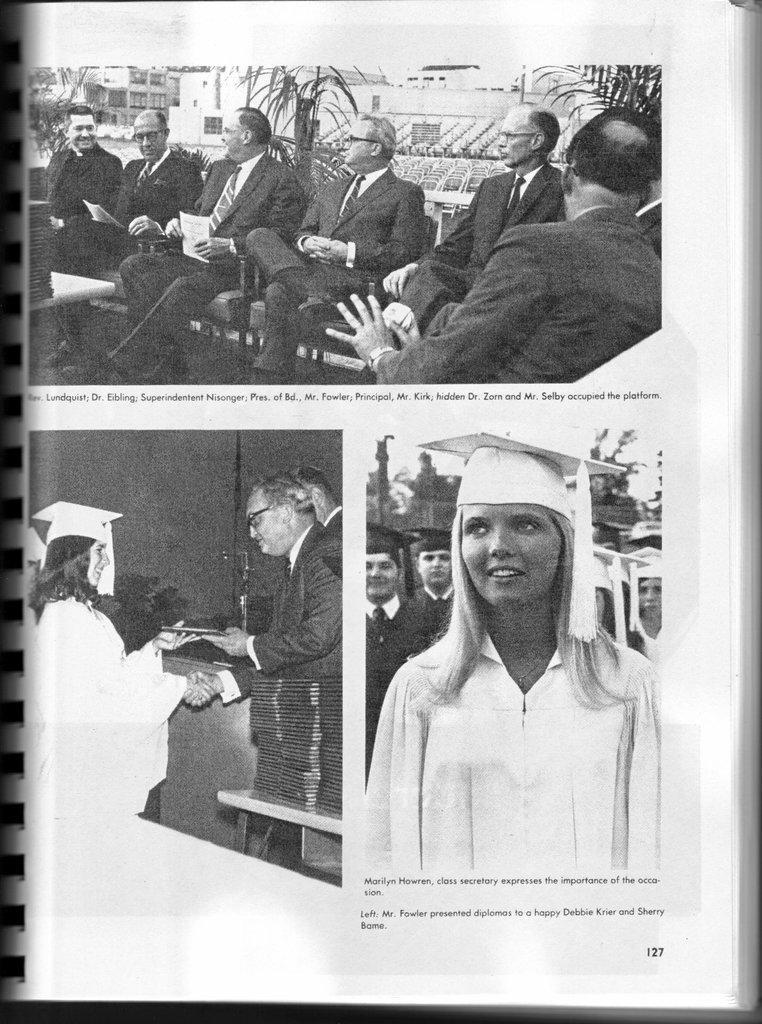Could you give a brief overview of what you see in this image? This is a black and white pic. At the top of the image we can see few persons are sitting on the chairs and among them few persons are holding papers in their hands. In the background we can see plants, buildings and sky. On the left side we can see a man giving an object to the woman and shook their hands and in the background we can see a person. On the right side we can see a woman and there is a cap on her head and in the background we can see few persons and sky. 